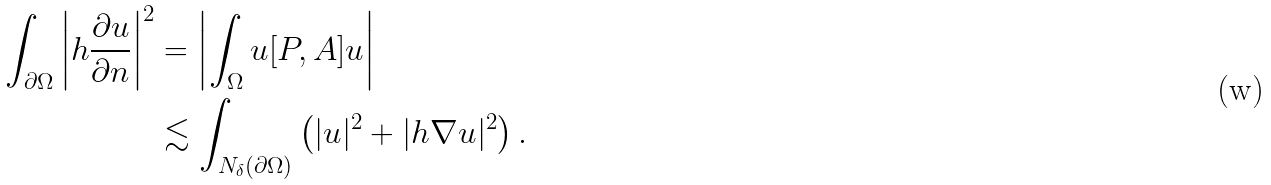Convert formula to latex. <formula><loc_0><loc_0><loc_500><loc_500>\int _ { \partial \Omega } \left | h \frac { \partial u } { \partial n } \right | ^ { 2 } & = \left | \int _ { \Omega } u [ P , A ] u \right | \\ & \lesssim \int _ { N _ { \delta } ( \partial \Omega ) } \left ( | u | ^ { 2 } + | h \nabla u | ^ { 2 } \right ) .</formula> 